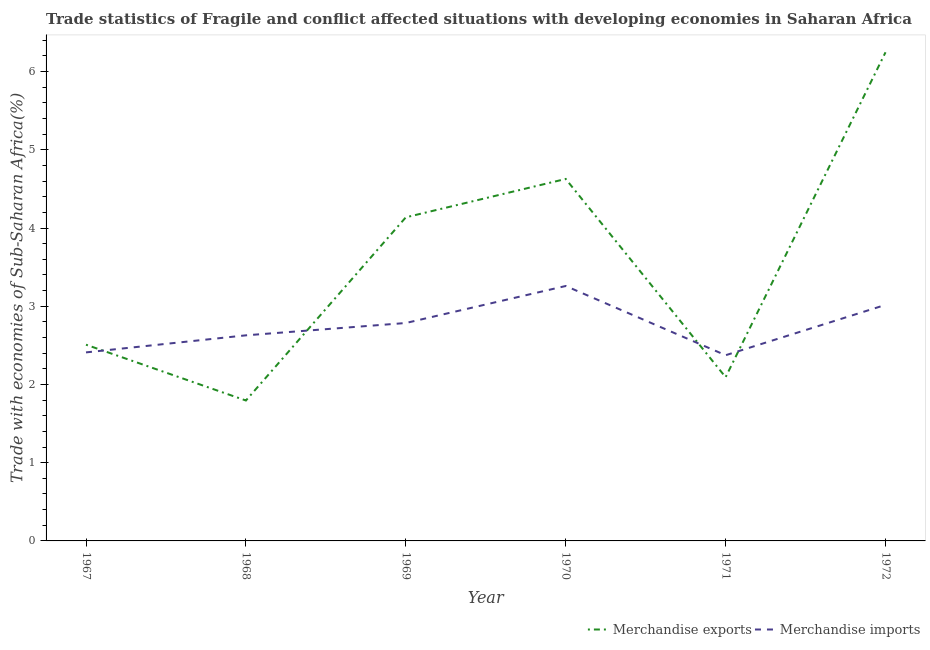How many different coloured lines are there?
Your answer should be very brief. 2. What is the merchandise imports in 1967?
Your answer should be very brief. 2.41. Across all years, what is the maximum merchandise imports?
Offer a very short reply. 3.26. Across all years, what is the minimum merchandise exports?
Your answer should be very brief. 1.8. In which year was the merchandise exports minimum?
Offer a terse response. 1968. What is the total merchandise imports in the graph?
Keep it short and to the point. 16.48. What is the difference between the merchandise imports in 1967 and that in 1971?
Provide a short and direct response. 0.04. What is the difference between the merchandise exports in 1967 and the merchandise imports in 1968?
Offer a very short reply. -0.12. What is the average merchandise exports per year?
Your answer should be very brief. 3.57. In the year 1969, what is the difference between the merchandise exports and merchandise imports?
Your response must be concise. 1.35. In how many years, is the merchandise imports greater than 1.8 %?
Your answer should be compact. 6. What is the ratio of the merchandise imports in 1968 to that in 1971?
Offer a terse response. 1.11. Is the merchandise imports in 1968 less than that in 1969?
Keep it short and to the point. Yes. Is the difference between the merchandise imports in 1967 and 1970 greater than the difference between the merchandise exports in 1967 and 1970?
Your answer should be very brief. Yes. What is the difference between the highest and the second highest merchandise imports?
Your response must be concise. 0.24. What is the difference between the highest and the lowest merchandise exports?
Give a very brief answer. 4.45. In how many years, is the merchandise exports greater than the average merchandise exports taken over all years?
Make the answer very short. 3. Is the merchandise exports strictly less than the merchandise imports over the years?
Give a very brief answer. No. How many years are there in the graph?
Keep it short and to the point. 6. Does the graph contain any zero values?
Offer a terse response. No. Does the graph contain grids?
Provide a short and direct response. No. Where does the legend appear in the graph?
Offer a very short reply. Bottom right. How are the legend labels stacked?
Provide a succinct answer. Horizontal. What is the title of the graph?
Keep it short and to the point. Trade statistics of Fragile and conflict affected situations with developing economies in Saharan Africa. What is the label or title of the Y-axis?
Make the answer very short. Trade with economies of Sub-Saharan Africa(%). What is the Trade with economies of Sub-Saharan Africa(%) of Merchandise exports in 1967?
Give a very brief answer. 2.51. What is the Trade with economies of Sub-Saharan Africa(%) of Merchandise imports in 1967?
Provide a succinct answer. 2.41. What is the Trade with economies of Sub-Saharan Africa(%) in Merchandise exports in 1968?
Your answer should be very brief. 1.8. What is the Trade with economies of Sub-Saharan Africa(%) in Merchandise imports in 1968?
Provide a succinct answer. 2.63. What is the Trade with economies of Sub-Saharan Africa(%) in Merchandise exports in 1969?
Provide a short and direct response. 4.14. What is the Trade with economies of Sub-Saharan Africa(%) in Merchandise imports in 1969?
Provide a short and direct response. 2.79. What is the Trade with economies of Sub-Saharan Africa(%) of Merchandise exports in 1970?
Make the answer very short. 4.63. What is the Trade with economies of Sub-Saharan Africa(%) in Merchandise imports in 1970?
Keep it short and to the point. 3.26. What is the Trade with economies of Sub-Saharan Africa(%) in Merchandise exports in 1971?
Offer a terse response. 2.09. What is the Trade with economies of Sub-Saharan Africa(%) of Merchandise imports in 1971?
Keep it short and to the point. 2.37. What is the Trade with economies of Sub-Saharan Africa(%) in Merchandise exports in 1972?
Offer a very short reply. 6.25. What is the Trade with economies of Sub-Saharan Africa(%) in Merchandise imports in 1972?
Your response must be concise. 3.02. Across all years, what is the maximum Trade with economies of Sub-Saharan Africa(%) of Merchandise exports?
Give a very brief answer. 6.25. Across all years, what is the maximum Trade with economies of Sub-Saharan Africa(%) in Merchandise imports?
Ensure brevity in your answer.  3.26. Across all years, what is the minimum Trade with economies of Sub-Saharan Africa(%) in Merchandise exports?
Ensure brevity in your answer.  1.8. Across all years, what is the minimum Trade with economies of Sub-Saharan Africa(%) of Merchandise imports?
Your response must be concise. 2.37. What is the total Trade with economies of Sub-Saharan Africa(%) in Merchandise exports in the graph?
Your response must be concise. 21.41. What is the total Trade with economies of Sub-Saharan Africa(%) of Merchandise imports in the graph?
Keep it short and to the point. 16.48. What is the difference between the Trade with economies of Sub-Saharan Africa(%) of Merchandise exports in 1967 and that in 1968?
Your response must be concise. 0.71. What is the difference between the Trade with economies of Sub-Saharan Africa(%) of Merchandise imports in 1967 and that in 1968?
Provide a succinct answer. -0.22. What is the difference between the Trade with economies of Sub-Saharan Africa(%) of Merchandise exports in 1967 and that in 1969?
Ensure brevity in your answer.  -1.63. What is the difference between the Trade with economies of Sub-Saharan Africa(%) in Merchandise imports in 1967 and that in 1969?
Your answer should be compact. -0.38. What is the difference between the Trade with economies of Sub-Saharan Africa(%) in Merchandise exports in 1967 and that in 1970?
Your response must be concise. -2.12. What is the difference between the Trade with economies of Sub-Saharan Africa(%) in Merchandise imports in 1967 and that in 1970?
Offer a terse response. -0.85. What is the difference between the Trade with economies of Sub-Saharan Africa(%) in Merchandise exports in 1967 and that in 1971?
Offer a terse response. 0.42. What is the difference between the Trade with economies of Sub-Saharan Africa(%) in Merchandise imports in 1967 and that in 1971?
Provide a succinct answer. 0.04. What is the difference between the Trade with economies of Sub-Saharan Africa(%) in Merchandise exports in 1967 and that in 1972?
Provide a short and direct response. -3.74. What is the difference between the Trade with economies of Sub-Saharan Africa(%) in Merchandise imports in 1967 and that in 1972?
Provide a succinct answer. -0.61. What is the difference between the Trade with economies of Sub-Saharan Africa(%) of Merchandise exports in 1968 and that in 1969?
Keep it short and to the point. -2.34. What is the difference between the Trade with economies of Sub-Saharan Africa(%) in Merchandise imports in 1968 and that in 1969?
Your answer should be compact. -0.16. What is the difference between the Trade with economies of Sub-Saharan Africa(%) in Merchandise exports in 1968 and that in 1970?
Give a very brief answer. -2.83. What is the difference between the Trade with economies of Sub-Saharan Africa(%) in Merchandise imports in 1968 and that in 1970?
Offer a very short reply. -0.63. What is the difference between the Trade with economies of Sub-Saharan Africa(%) in Merchandise exports in 1968 and that in 1971?
Ensure brevity in your answer.  -0.3. What is the difference between the Trade with economies of Sub-Saharan Africa(%) in Merchandise imports in 1968 and that in 1971?
Offer a very short reply. 0.25. What is the difference between the Trade with economies of Sub-Saharan Africa(%) in Merchandise exports in 1968 and that in 1972?
Make the answer very short. -4.45. What is the difference between the Trade with economies of Sub-Saharan Africa(%) in Merchandise imports in 1968 and that in 1972?
Your answer should be compact. -0.39. What is the difference between the Trade with economies of Sub-Saharan Africa(%) in Merchandise exports in 1969 and that in 1970?
Your response must be concise. -0.49. What is the difference between the Trade with economies of Sub-Saharan Africa(%) in Merchandise imports in 1969 and that in 1970?
Ensure brevity in your answer.  -0.47. What is the difference between the Trade with economies of Sub-Saharan Africa(%) of Merchandise exports in 1969 and that in 1971?
Make the answer very short. 2.04. What is the difference between the Trade with economies of Sub-Saharan Africa(%) in Merchandise imports in 1969 and that in 1971?
Your response must be concise. 0.41. What is the difference between the Trade with economies of Sub-Saharan Africa(%) in Merchandise exports in 1969 and that in 1972?
Offer a terse response. -2.11. What is the difference between the Trade with economies of Sub-Saharan Africa(%) in Merchandise imports in 1969 and that in 1972?
Ensure brevity in your answer.  -0.23. What is the difference between the Trade with economies of Sub-Saharan Africa(%) of Merchandise exports in 1970 and that in 1971?
Give a very brief answer. 2.53. What is the difference between the Trade with economies of Sub-Saharan Africa(%) of Merchandise imports in 1970 and that in 1971?
Offer a terse response. 0.89. What is the difference between the Trade with economies of Sub-Saharan Africa(%) of Merchandise exports in 1970 and that in 1972?
Keep it short and to the point. -1.62. What is the difference between the Trade with economies of Sub-Saharan Africa(%) of Merchandise imports in 1970 and that in 1972?
Your answer should be compact. 0.24. What is the difference between the Trade with economies of Sub-Saharan Africa(%) in Merchandise exports in 1971 and that in 1972?
Your response must be concise. -4.15. What is the difference between the Trade with economies of Sub-Saharan Africa(%) in Merchandise imports in 1971 and that in 1972?
Provide a succinct answer. -0.64. What is the difference between the Trade with economies of Sub-Saharan Africa(%) of Merchandise exports in 1967 and the Trade with economies of Sub-Saharan Africa(%) of Merchandise imports in 1968?
Your answer should be compact. -0.12. What is the difference between the Trade with economies of Sub-Saharan Africa(%) in Merchandise exports in 1967 and the Trade with economies of Sub-Saharan Africa(%) in Merchandise imports in 1969?
Give a very brief answer. -0.28. What is the difference between the Trade with economies of Sub-Saharan Africa(%) in Merchandise exports in 1967 and the Trade with economies of Sub-Saharan Africa(%) in Merchandise imports in 1970?
Offer a terse response. -0.75. What is the difference between the Trade with economies of Sub-Saharan Africa(%) in Merchandise exports in 1967 and the Trade with economies of Sub-Saharan Africa(%) in Merchandise imports in 1971?
Offer a terse response. 0.13. What is the difference between the Trade with economies of Sub-Saharan Africa(%) of Merchandise exports in 1967 and the Trade with economies of Sub-Saharan Africa(%) of Merchandise imports in 1972?
Make the answer very short. -0.51. What is the difference between the Trade with economies of Sub-Saharan Africa(%) of Merchandise exports in 1968 and the Trade with economies of Sub-Saharan Africa(%) of Merchandise imports in 1969?
Give a very brief answer. -0.99. What is the difference between the Trade with economies of Sub-Saharan Africa(%) in Merchandise exports in 1968 and the Trade with economies of Sub-Saharan Africa(%) in Merchandise imports in 1970?
Offer a very short reply. -1.46. What is the difference between the Trade with economies of Sub-Saharan Africa(%) of Merchandise exports in 1968 and the Trade with economies of Sub-Saharan Africa(%) of Merchandise imports in 1971?
Offer a very short reply. -0.58. What is the difference between the Trade with economies of Sub-Saharan Africa(%) in Merchandise exports in 1968 and the Trade with economies of Sub-Saharan Africa(%) in Merchandise imports in 1972?
Offer a very short reply. -1.22. What is the difference between the Trade with economies of Sub-Saharan Africa(%) of Merchandise exports in 1969 and the Trade with economies of Sub-Saharan Africa(%) of Merchandise imports in 1970?
Provide a succinct answer. 0.88. What is the difference between the Trade with economies of Sub-Saharan Africa(%) of Merchandise exports in 1969 and the Trade with economies of Sub-Saharan Africa(%) of Merchandise imports in 1971?
Give a very brief answer. 1.76. What is the difference between the Trade with economies of Sub-Saharan Africa(%) of Merchandise exports in 1969 and the Trade with economies of Sub-Saharan Africa(%) of Merchandise imports in 1972?
Offer a terse response. 1.12. What is the difference between the Trade with economies of Sub-Saharan Africa(%) in Merchandise exports in 1970 and the Trade with economies of Sub-Saharan Africa(%) in Merchandise imports in 1971?
Keep it short and to the point. 2.25. What is the difference between the Trade with economies of Sub-Saharan Africa(%) in Merchandise exports in 1970 and the Trade with economies of Sub-Saharan Africa(%) in Merchandise imports in 1972?
Give a very brief answer. 1.61. What is the difference between the Trade with economies of Sub-Saharan Africa(%) of Merchandise exports in 1971 and the Trade with economies of Sub-Saharan Africa(%) of Merchandise imports in 1972?
Provide a short and direct response. -0.92. What is the average Trade with economies of Sub-Saharan Africa(%) of Merchandise exports per year?
Make the answer very short. 3.57. What is the average Trade with economies of Sub-Saharan Africa(%) of Merchandise imports per year?
Offer a very short reply. 2.75. In the year 1967, what is the difference between the Trade with economies of Sub-Saharan Africa(%) in Merchandise exports and Trade with economies of Sub-Saharan Africa(%) in Merchandise imports?
Provide a succinct answer. 0.1. In the year 1969, what is the difference between the Trade with economies of Sub-Saharan Africa(%) in Merchandise exports and Trade with economies of Sub-Saharan Africa(%) in Merchandise imports?
Provide a short and direct response. 1.35. In the year 1970, what is the difference between the Trade with economies of Sub-Saharan Africa(%) in Merchandise exports and Trade with economies of Sub-Saharan Africa(%) in Merchandise imports?
Provide a succinct answer. 1.37. In the year 1971, what is the difference between the Trade with economies of Sub-Saharan Africa(%) of Merchandise exports and Trade with economies of Sub-Saharan Africa(%) of Merchandise imports?
Offer a terse response. -0.28. In the year 1972, what is the difference between the Trade with economies of Sub-Saharan Africa(%) in Merchandise exports and Trade with economies of Sub-Saharan Africa(%) in Merchandise imports?
Make the answer very short. 3.23. What is the ratio of the Trade with economies of Sub-Saharan Africa(%) in Merchandise exports in 1967 to that in 1968?
Provide a succinct answer. 1.4. What is the ratio of the Trade with economies of Sub-Saharan Africa(%) of Merchandise imports in 1967 to that in 1968?
Keep it short and to the point. 0.92. What is the ratio of the Trade with economies of Sub-Saharan Africa(%) in Merchandise exports in 1967 to that in 1969?
Give a very brief answer. 0.61. What is the ratio of the Trade with economies of Sub-Saharan Africa(%) of Merchandise imports in 1967 to that in 1969?
Ensure brevity in your answer.  0.87. What is the ratio of the Trade with economies of Sub-Saharan Africa(%) of Merchandise exports in 1967 to that in 1970?
Ensure brevity in your answer.  0.54. What is the ratio of the Trade with economies of Sub-Saharan Africa(%) in Merchandise imports in 1967 to that in 1970?
Your response must be concise. 0.74. What is the ratio of the Trade with economies of Sub-Saharan Africa(%) of Merchandise exports in 1967 to that in 1971?
Ensure brevity in your answer.  1.2. What is the ratio of the Trade with economies of Sub-Saharan Africa(%) of Merchandise imports in 1967 to that in 1971?
Provide a short and direct response. 1.02. What is the ratio of the Trade with economies of Sub-Saharan Africa(%) in Merchandise exports in 1967 to that in 1972?
Give a very brief answer. 0.4. What is the ratio of the Trade with economies of Sub-Saharan Africa(%) of Merchandise imports in 1967 to that in 1972?
Provide a succinct answer. 0.8. What is the ratio of the Trade with economies of Sub-Saharan Africa(%) in Merchandise exports in 1968 to that in 1969?
Give a very brief answer. 0.43. What is the ratio of the Trade with economies of Sub-Saharan Africa(%) of Merchandise imports in 1968 to that in 1969?
Provide a short and direct response. 0.94. What is the ratio of the Trade with economies of Sub-Saharan Africa(%) of Merchandise exports in 1968 to that in 1970?
Your response must be concise. 0.39. What is the ratio of the Trade with economies of Sub-Saharan Africa(%) in Merchandise imports in 1968 to that in 1970?
Offer a terse response. 0.81. What is the ratio of the Trade with economies of Sub-Saharan Africa(%) in Merchandise exports in 1968 to that in 1971?
Provide a succinct answer. 0.86. What is the ratio of the Trade with economies of Sub-Saharan Africa(%) of Merchandise imports in 1968 to that in 1971?
Offer a very short reply. 1.11. What is the ratio of the Trade with economies of Sub-Saharan Africa(%) of Merchandise exports in 1968 to that in 1972?
Provide a short and direct response. 0.29. What is the ratio of the Trade with economies of Sub-Saharan Africa(%) in Merchandise imports in 1968 to that in 1972?
Give a very brief answer. 0.87. What is the ratio of the Trade with economies of Sub-Saharan Africa(%) of Merchandise exports in 1969 to that in 1970?
Your response must be concise. 0.89. What is the ratio of the Trade with economies of Sub-Saharan Africa(%) of Merchandise imports in 1969 to that in 1970?
Give a very brief answer. 0.85. What is the ratio of the Trade with economies of Sub-Saharan Africa(%) in Merchandise exports in 1969 to that in 1971?
Your response must be concise. 1.98. What is the ratio of the Trade with economies of Sub-Saharan Africa(%) of Merchandise imports in 1969 to that in 1971?
Your answer should be very brief. 1.17. What is the ratio of the Trade with economies of Sub-Saharan Africa(%) in Merchandise exports in 1969 to that in 1972?
Make the answer very short. 0.66. What is the ratio of the Trade with economies of Sub-Saharan Africa(%) in Merchandise imports in 1969 to that in 1972?
Keep it short and to the point. 0.92. What is the ratio of the Trade with economies of Sub-Saharan Africa(%) of Merchandise exports in 1970 to that in 1971?
Your answer should be compact. 2.21. What is the ratio of the Trade with economies of Sub-Saharan Africa(%) of Merchandise imports in 1970 to that in 1971?
Make the answer very short. 1.37. What is the ratio of the Trade with economies of Sub-Saharan Africa(%) of Merchandise exports in 1970 to that in 1972?
Ensure brevity in your answer.  0.74. What is the ratio of the Trade with economies of Sub-Saharan Africa(%) of Merchandise imports in 1970 to that in 1972?
Ensure brevity in your answer.  1.08. What is the ratio of the Trade with economies of Sub-Saharan Africa(%) of Merchandise exports in 1971 to that in 1972?
Ensure brevity in your answer.  0.34. What is the ratio of the Trade with economies of Sub-Saharan Africa(%) of Merchandise imports in 1971 to that in 1972?
Your response must be concise. 0.79. What is the difference between the highest and the second highest Trade with economies of Sub-Saharan Africa(%) in Merchandise exports?
Your response must be concise. 1.62. What is the difference between the highest and the second highest Trade with economies of Sub-Saharan Africa(%) of Merchandise imports?
Give a very brief answer. 0.24. What is the difference between the highest and the lowest Trade with economies of Sub-Saharan Africa(%) of Merchandise exports?
Keep it short and to the point. 4.45. What is the difference between the highest and the lowest Trade with economies of Sub-Saharan Africa(%) of Merchandise imports?
Provide a short and direct response. 0.89. 